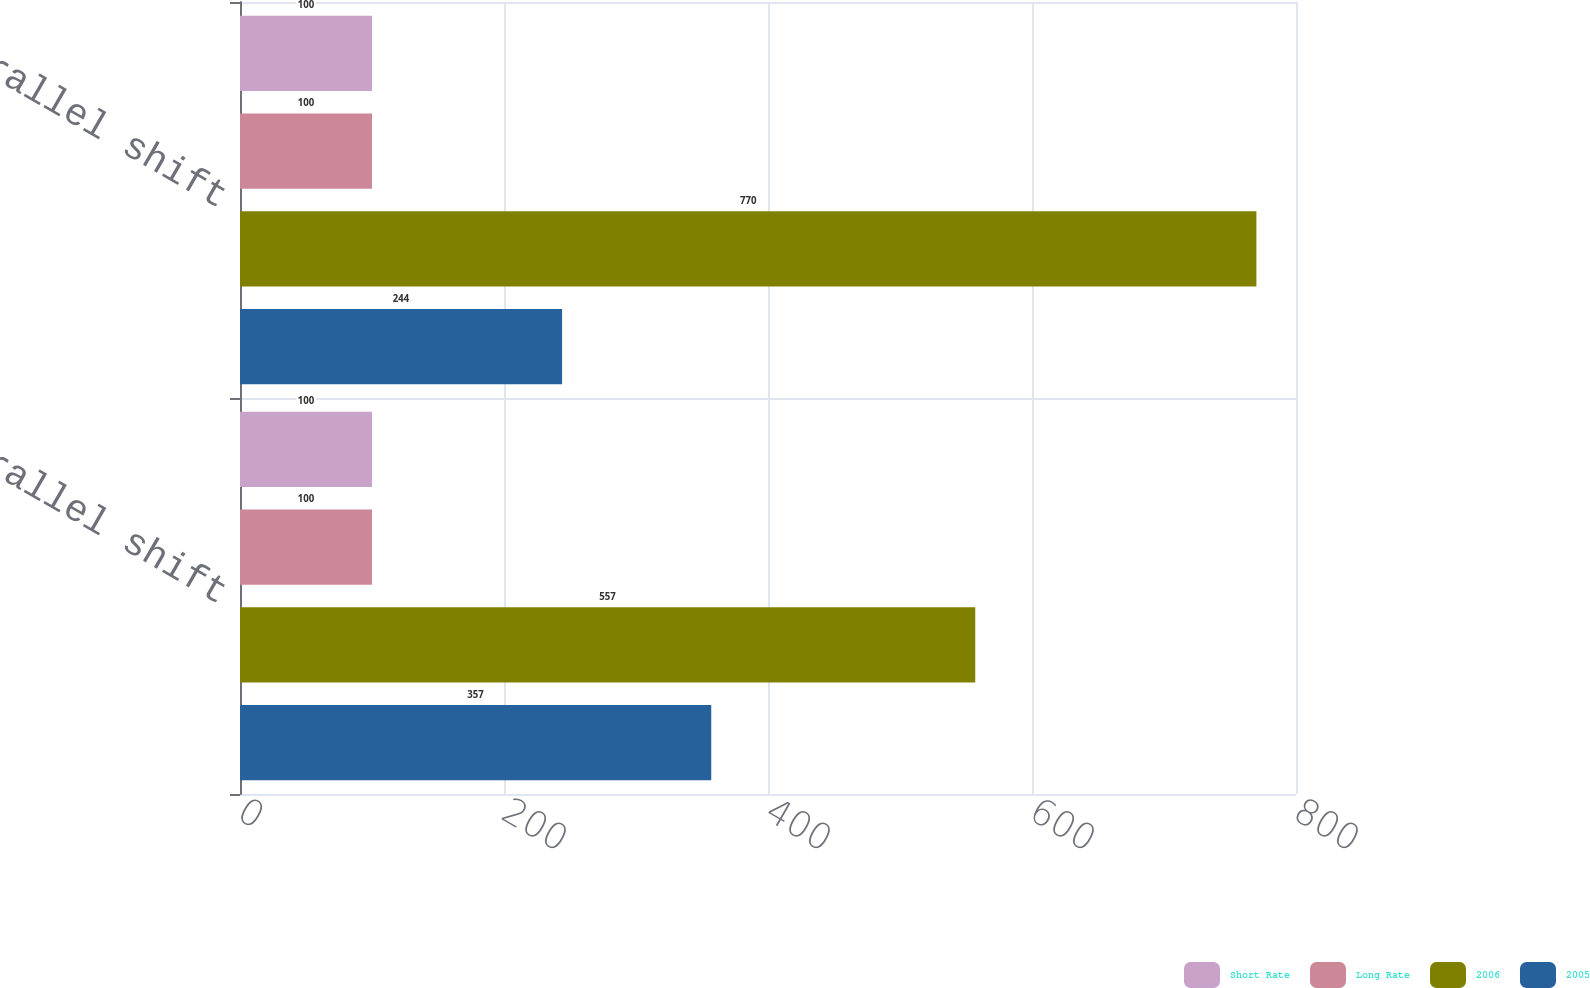Convert chart to OTSL. <chart><loc_0><loc_0><loc_500><loc_500><stacked_bar_chart><ecel><fcel>+100 Parallel shift<fcel>-100 Parallel shift<nl><fcel>Short Rate<fcel>100<fcel>100<nl><fcel>Long Rate<fcel>100<fcel>100<nl><fcel>2006<fcel>557<fcel>770<nl><fcel>2005<fcel>357<fcel>244<nl></chart> 